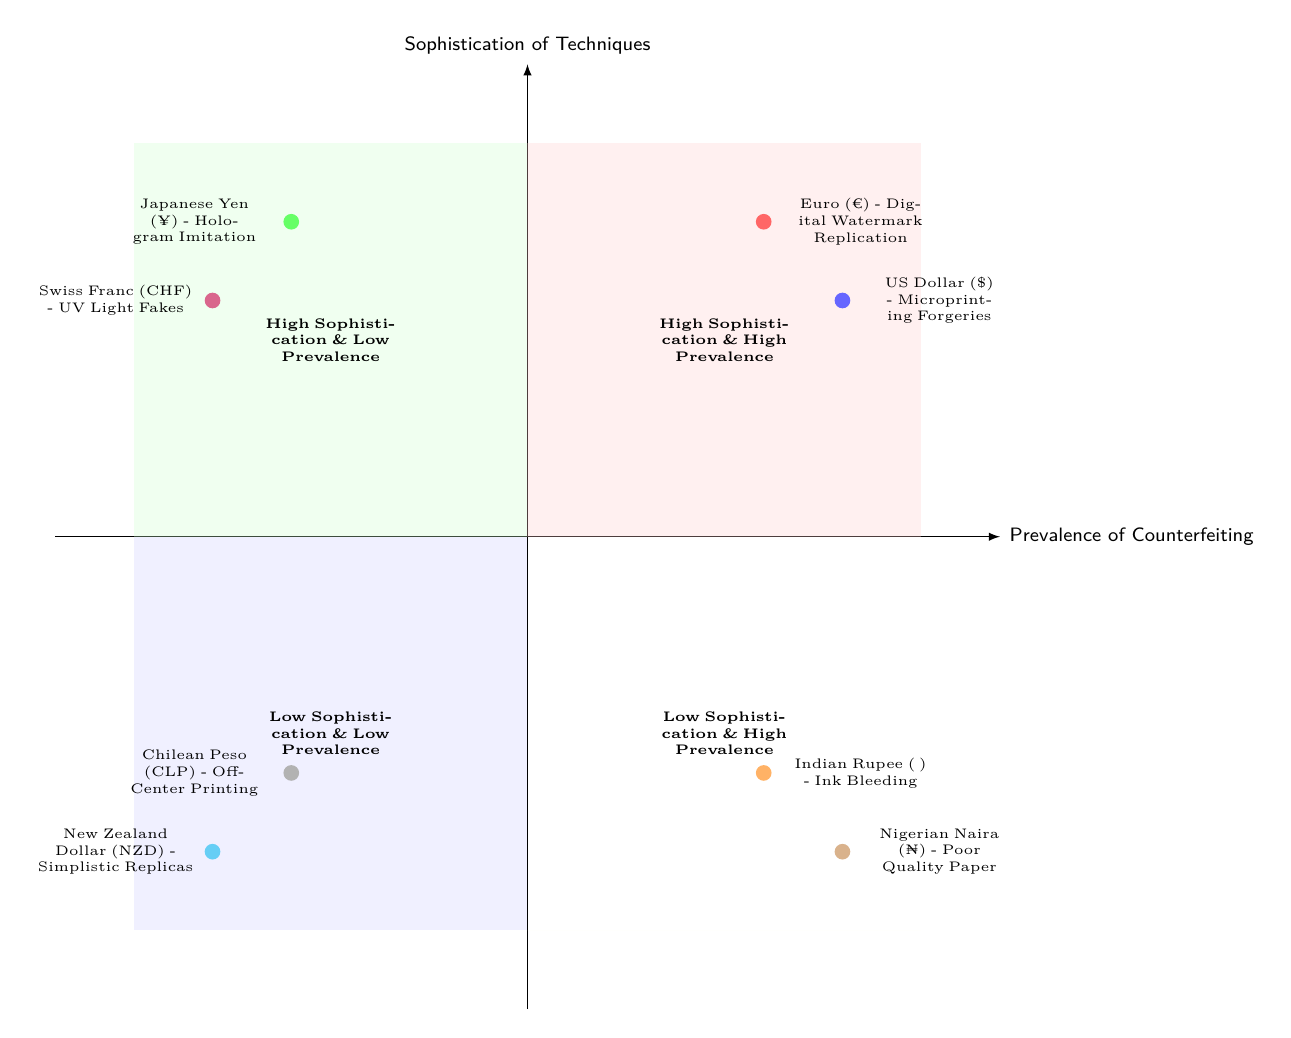What elements are found in the "High Sophistication & High Prevalence" quadrant? In the "High Sophistication & High Prevalence" quadrant, the elements listed are "Euro (€) - Digital Watermark Replication" and "US Dollar ($) - Microprinting Forgeries."
Answer: Euro (€) - Digital Watermark Replication, US Dollar ($) - Microprinting Forgeries How many elements are in the "Low Sophistication & Low Prevalence" quadrant? The "Low Sophistication & Low Prevalence" quadrant contains two elements: "Chilean Peso (CLP) - Off-Center Printing" and "New Zealand Dollar (NZD) - Simplistic Replicas." Therefore, the count is two.
Answer: 2 Which currency is associated with hologram imitation? The currency associated with hologram imitation, as shown in the diagram, is the "Japanese Yen (¥) - Hologram Imitation."
Answer: Japanese Yen (¥) - Hologram Imitation What is the commonality between the elements in the "Low Sophistication & High Prevalence" quadrant? The commonality between the elements in the "Low Sophistication & High Prevalence" quadrant is that both "Indian Rupee (₹) - Ink Bleeding" and "Nigerian Naira (₦) - Poor Quality Paper" are characterized by lower-level techniques that are frequently used, indicating a prevalence of lower-quality counterfeits.
Answer: Ink Bleeding, Poor Quality Paper Which quadrant contains the Swiss Franc (CHF)? The Swiss Franc (CHF) is located in the "High Sophistication & Low Prevalence" quadrant, indicated by its description as "Swiss Franc (CHF) - UV Light Fakes."
Answer: High Sophistication & Low Prevalence 